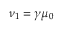Convert formula to latex. <formula><loc_0><loc_0><loc_500><loc_500>\nu _ { 1 } = \gamma \mu _ { 0 }</formula> 